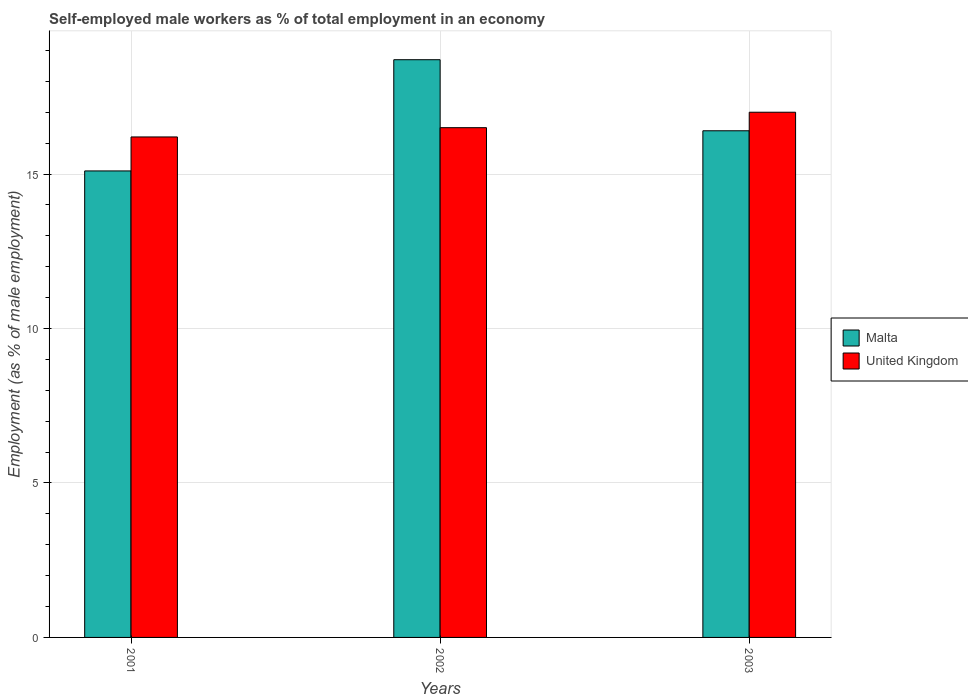Are the number of bars on each tick of the X-axis equal?
Offer a very short reply. Yes. How many bars are there on the 1st tick from the right?
Make the answer very short. 2. What is the label of the 2nd group of bars from the left?
Make the answer very short. 2002. In how many cases, is the number of bars for a given year not equal to the number of legend labels?
Your response must be concise. 0. What is the percentage of self-employed male workers in United Kingdom in 2001?
Your answer should be compact. 16.2. Across all years, what is the maximum percentage of self-employed male workers in Malta?
Offer a terse response. 18.7. Across all years, what is the minimum percentage of self-employed male workers in Malta?
Offer a very short reply. 15.1. What is the total percentage of self-employed male workers in United Kingdom in the graph?
Offer a terse response. 49.7. What is the difference between the percentage of self-employed male workers in Malta in 2001 and that in 2003?
Your response must be concise. -1.3. What is the average percentage of self-employed male workers in Malta per year?
Make the answer very short. 16.73. In the year 2002, what is the difference between the percentage of self-employed male workers in Malta and percentage of self-employed male workers in United Kingdom?
Provide a succinct answer. 2.2. In how many years, is the percentage of self-employed male workers in Malta greater than 12 %?
Ensure brevity in your answer.  3. What is the ratio of the percentage of self-employed male workers in Malta in 2001 to that in 2002?
Keep it short and to the point. 0.81. Is the difference between the percentage of self-employed male workers in Malta in 2001 and 2002 greater than the difference between the percentage of self-employed male workers in United Kingdom in 2001 and 2002?
Ensure brevity in your answer.  No. What is the difference between the highest and the second highest percentage of self-employed male workers in Malta?
Make the answer very short. 2.3. What is the difference between the highest and the lowest percentage of self-employed male workers in Malta?
Give a very brief answer. 3.6. What does the 2nd bar from the left in 2001 represents?
Provide a short and direct response. United Kingdom. How many years are there in the graph?
Your answer should be very brief. 3. Are the values on the major ticks of Y-axis written in scientific E-notation?
Ensure brevity in your answer.  No. Does the graph contain any zero values?
Your answer should be compact. No. Does the graph contain grids?
Give a very brief answer. Yes. How many legend labels are there?
Offer a very short reply. 2. What is the title of the graph?
Ensure brevity in your answer.  Self-employed male workers as % of total employment in an economy. Does "Low & middle income" appear as one of the legend labels in the graph?
Your response must be concise. No. What is the label or title of the X-axis?
Keep it short and to the point. Years. What is the label or title of the Y-axis?
Ensure brevity in your answer.  Employment (as % of male employment). What is the Employment (as % of male employment) of Malta in 2001?
Your response must be concise. 15.1. What is the Employment (as % of male employment) in United Kingdom in 2001?
Ensure brevity in your answer.  16.2. What is the Employment (as % of male employment) of Malta in 2002?
Offer a very short reply. 18.7. What is the Employment (as % of male employment) of Malta in 2003?
Keep it short and to the point. 16.4. What is the Employment (as % of male employment) of United Kingdom in 2003?
Keep it short and to the point. 17. Across all years, what is the maximum Employment (as % of male employment) of Malta?
Your response must be concise. 18.7. Across all years, what is the maximum Employment (as % of male employment) of United Kingdom?
Your answer should be compact. 17. Across all years, what is the minimum Employment (as % of male employment) in Malta?
Your answer should be compact. 15.1. Across all years, what is the minimum Employment (as % of male employment) in United Kingdom?
Provide a short and direct response. 16.2. What is the total Employment (as % of male employment) in Malta in the graph?
Keep it short and to the point. 50.2. What is the total Employment (as % of male employment) of United Kingdom in the graph?
Provide a short and direct response. 49.7. What is the difference between the Employment (as % of male employment) of Malta in 2001 and that in 2002?
Make the answer very short. -3.6. What is the difference between the Employment (as % of male employment) in Malta in 2001 and that in 2003?
Ensure brevity in your answer.  -1.3. What is the difference between the Employment (as % of male employment) in United Kingdom in 2001 and that in 2003?
Offer a terse response. -0.8. What is the difference between the Employment (as % of male employment) in Malta in 2001 and the Employment (as % of male employment) in United Kingdom in 2002?
Your response must be concise. -1.4. What is the difference between the Employment (as % of male employment) of Malta in 2001 and the Employment (as % of male employment) of United Kingdom in 2003?
Your answer should be very brief. -1.9. What is the average Employment (as % of male employment) of Malta per year?
Offer a very short reply. 16.73. What is the average Employment (as % of male employment) in United Kingdom per year?
Give a very brief answer. 16.57. What is the ratio of the Employment (as % of male employment) in Malta in 2001 to that in 2002?
Make the answer very short. 0.81. What is the ratio of the Employment (as % of male employment) of United Kingdom in 2001 to that in 2002?
Provide a short and direct response. 0.98. What is the ratio of the Employment (as % of male employment) in Malta in 2001 to that in 2003?
Provide a succinct answer. 0.92. What is the ratio of the Employment (as % of male employment) in United Kingdom in 2001 to that in 2003?
Keep it short and to the point. 0.95. What is the ratio of the Employment (as % of male employment) in Malta in 2002 to that in 2003?
Your response must be concise. 1.14. What is the ratio of the Employment (as % of male employment) in United Kingdom in 2002 to that in 2003?
Provide a short and direct response. 0.97. What is the difference between the highest and the lowest Employment (as % of male employment) in Malta?
Provide a succinct answer. 3.6. What is the difference between the highest and the lowest Employment (as % of male employment) in United Kingdom?
Ensure brevity in your answer.  0.8. 